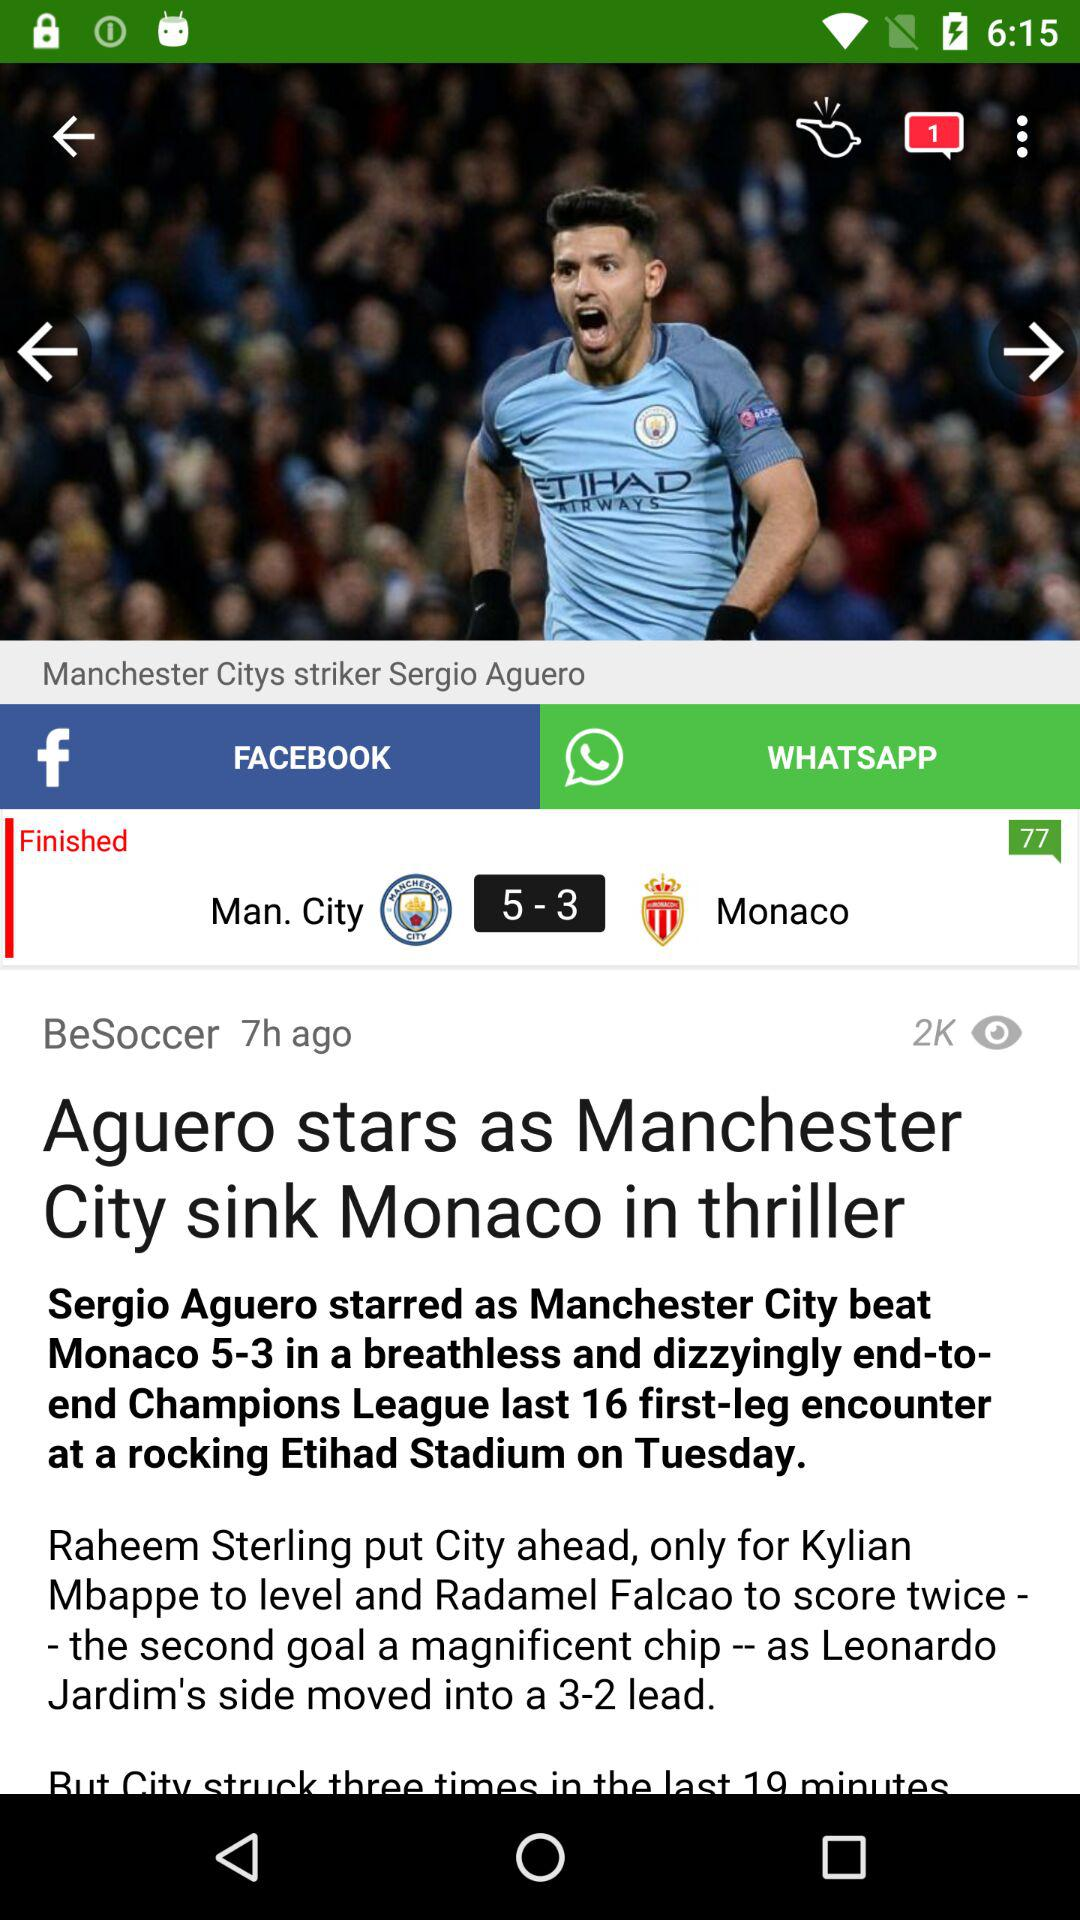How many goals did Monaco score?
Answer the question using a single word or phrase. 3 